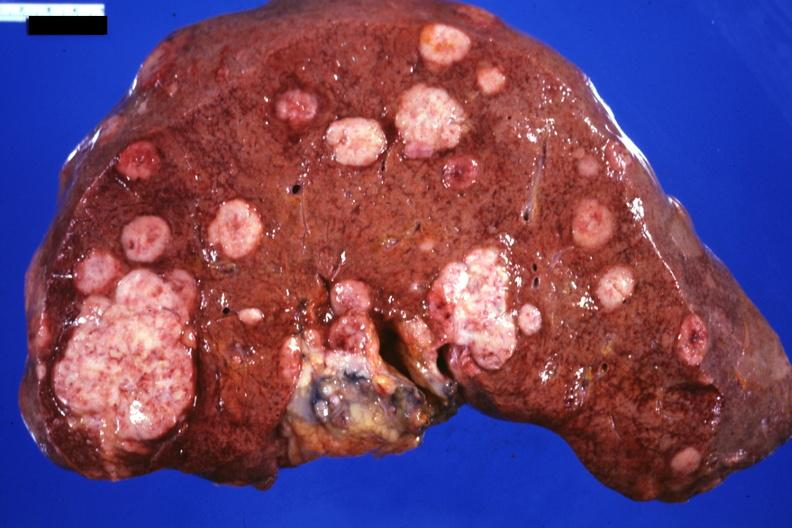what is present?
Answer the question using a single word or phrase. Hepatobiliary 